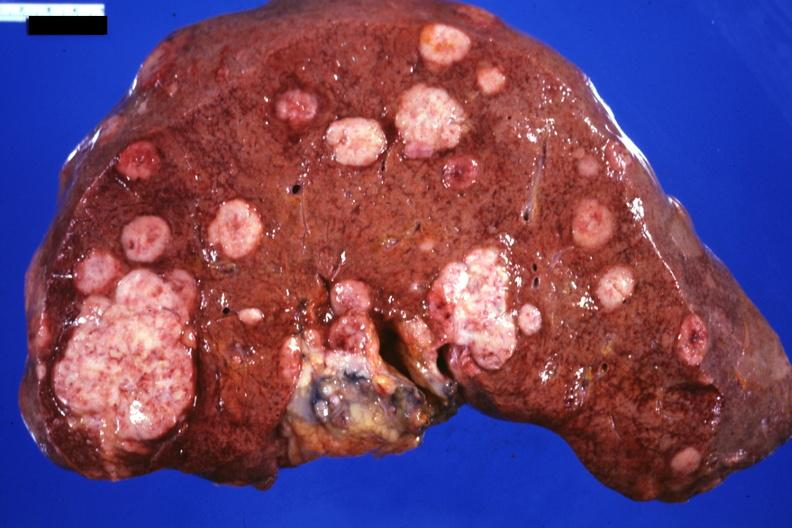what is present?
Answer the question using a single word or phrase. Hepatobiliary 